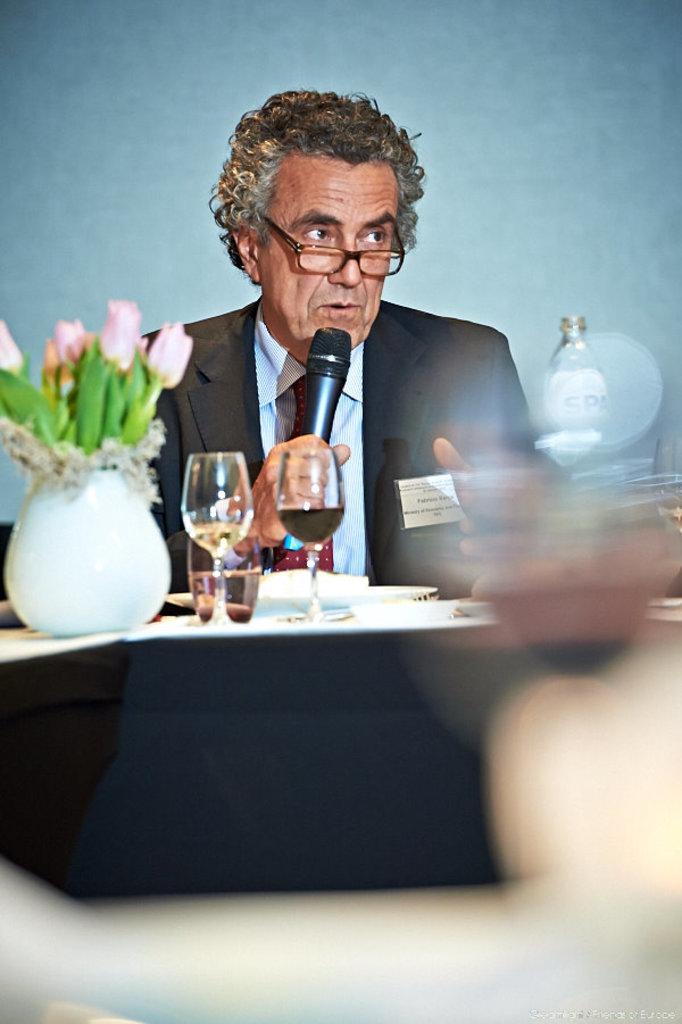In one or two sentences, can you explain what this image depicts? A man is speaking with a mic in his hand at a table with few wine glasses on it. 